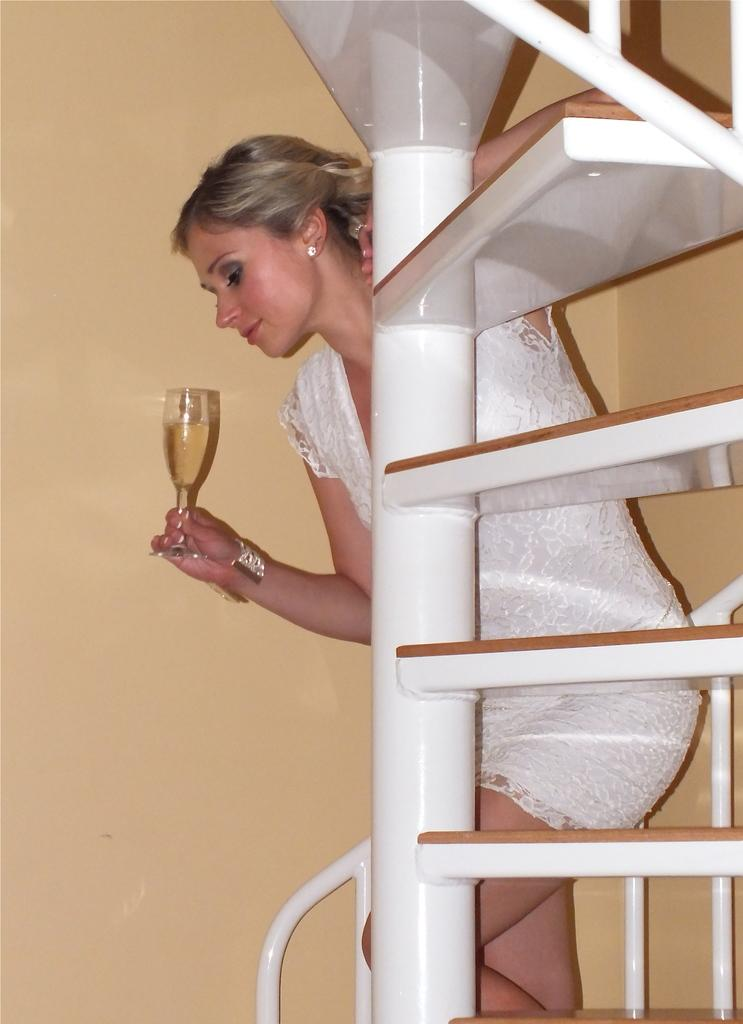What is the main subject of the image? There is a person in the image. What is the person doing in the image? The person is walking on the stairs. What is the person holding in the image? The person is holding a glass with a drink. What can be seen in the background of the image? There is a wall visible in the image. Can you hear the person playing a drum in the image? There is no drum present in the image, and therefore no sound of a drum can be heard. 